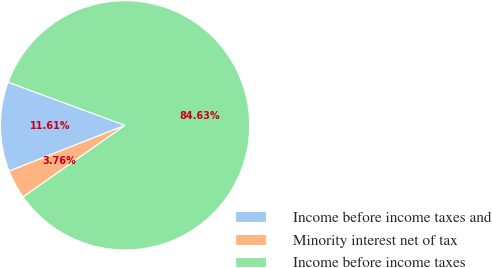Convert chart. <chart><loc_0><loc_0><loc_500><loc_500><pie_chart><fcel>Income before income taxes and<fcel>Minority interest net of tax<fcel>Income before income taxes<nl><fcel>11.61%<fcel>3.76%<fcel>84.63%<nl></chart> 